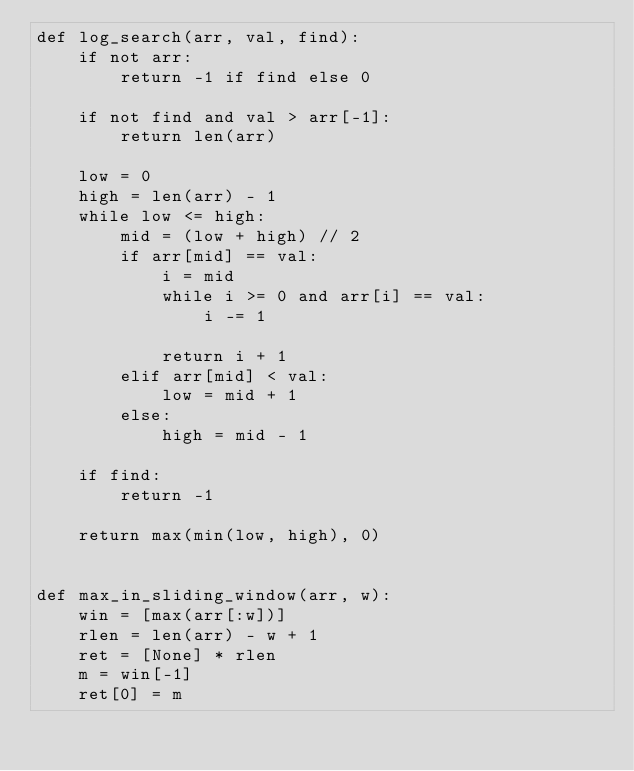<code> <loc_0><loc_0><loc_500><loc_500><_Python_>def log_search(arr, val, find):
    if not arr:
        return -1 if find else 0

    if not find and val > arr[-1]:
        return len(arr)

    low = 0
    high = len(arr) - 1
    while low <= high:
        mid = (low + high) // 2
        if arr[mid] == val:
            i = mid
            while i >= 0 and arr[i] == val:
                i -= 1

            return i + 1
        elif arr[mid] < val:
            low = mid + 1
        else:
            high = mid - 1

    if find:
        return -1

    return max(min(low, high), 0)


def max_in_sliding_window(arr, w):
    win = [max(arr[:w])]
    rlen = len(arr) - w + 1
    ret = [None] * rlen
    m = win[-1]
    ret[0] = m</code> 